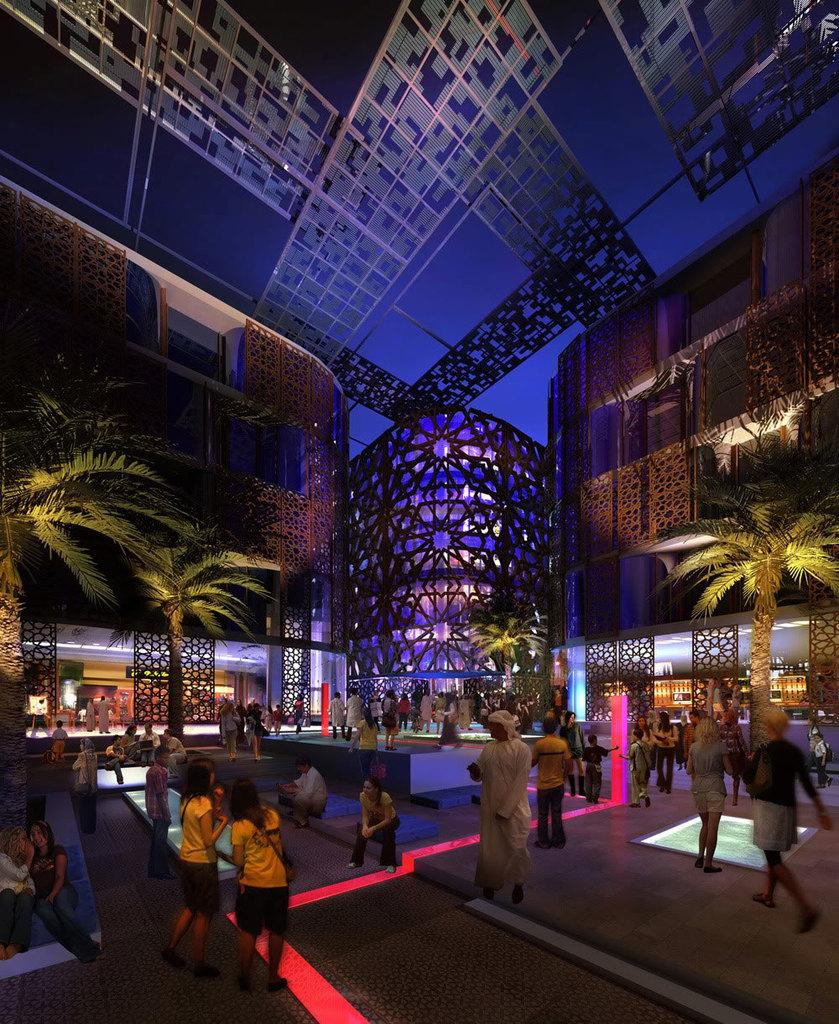Where was the image taken? The image was clicked outside. What is the main subject in the middle of the image? There is a building and trees in the middle of the image. Are there any people visible in the image? Yes, there are some persons at the bottom of the image. Can you see any veins in the trees in the image? There are no veins visible in the trees in the image, as veins are not a visible part of trees. 